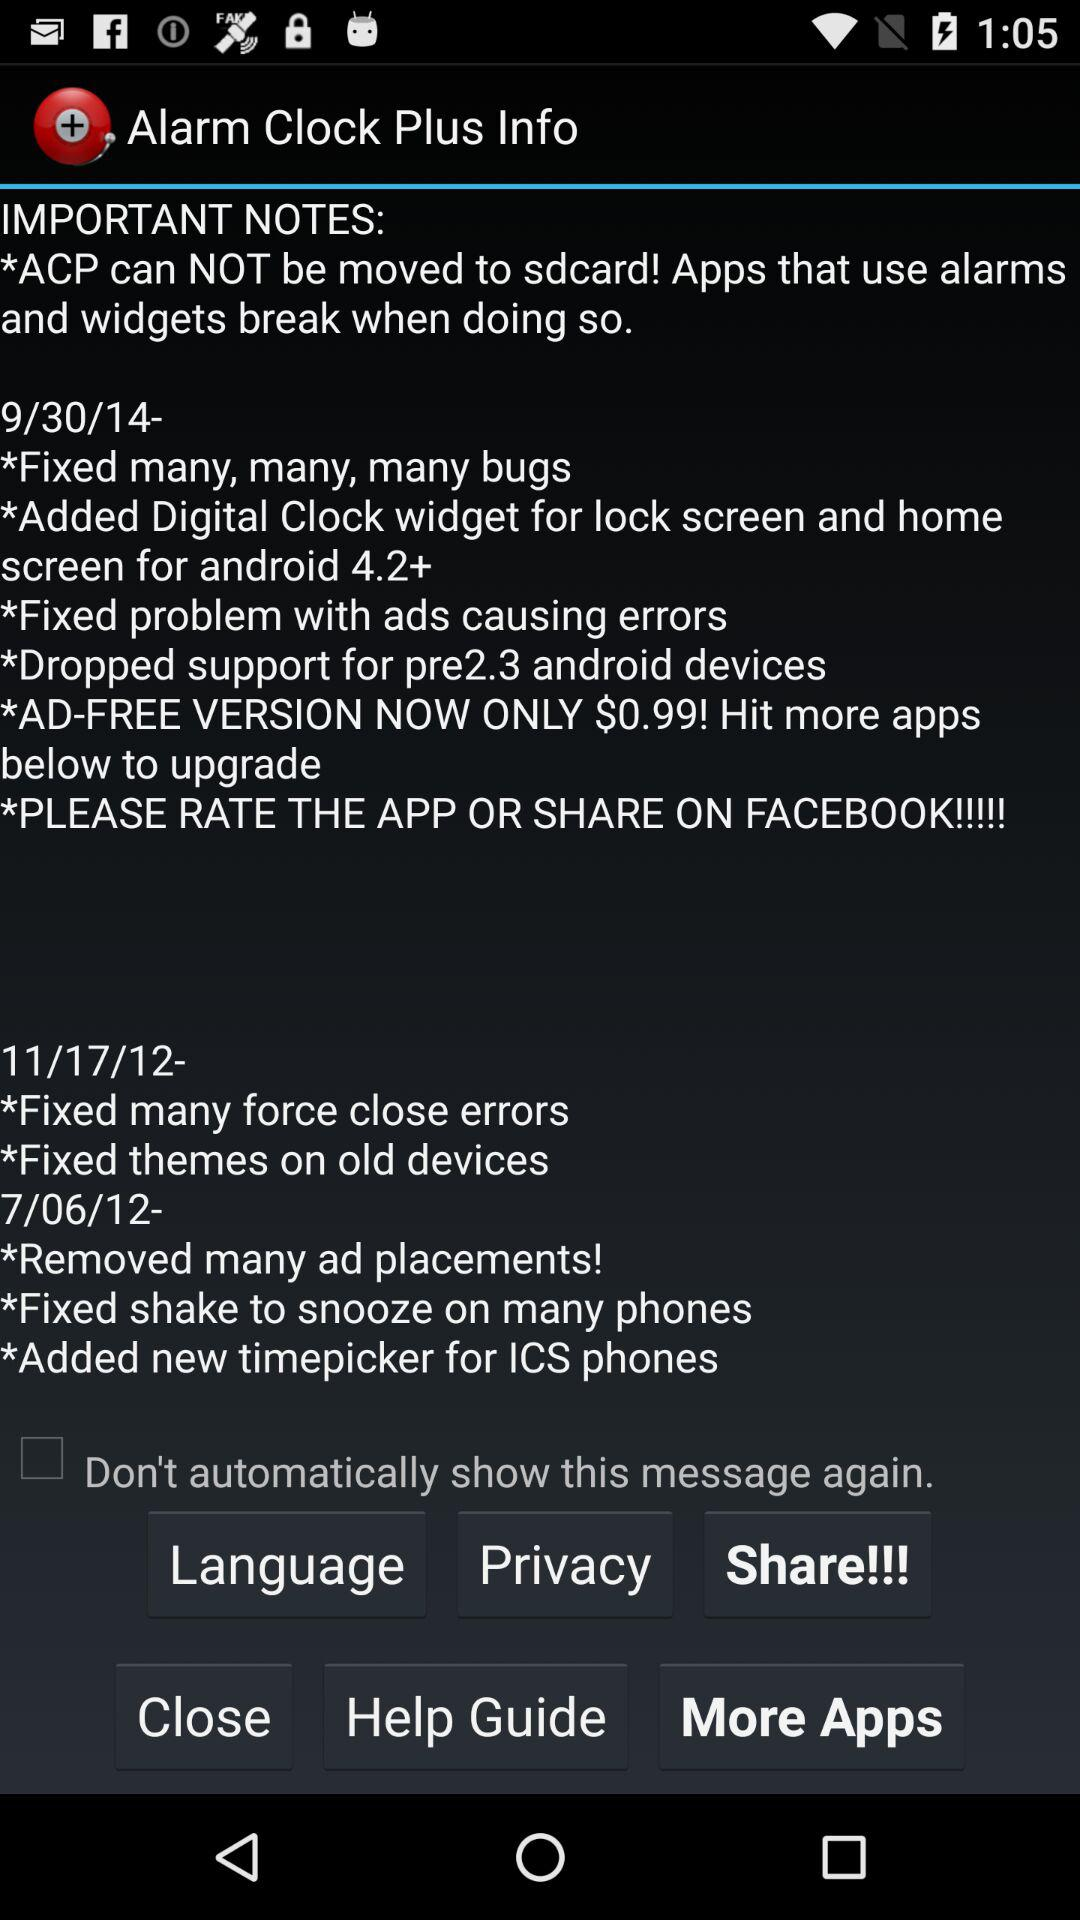Through which app can we share? You can share it with "FACEBOOK". 